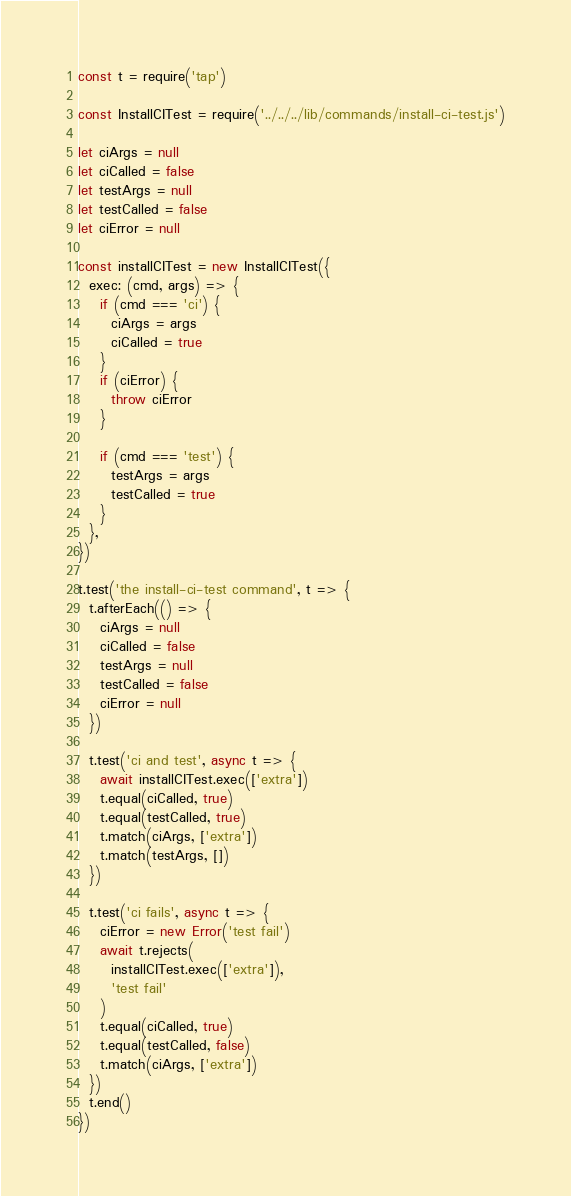<code> <loc_0><loc_0><loc_500><loc_500><_JavaScript_>const t = require('tap')

const InstallCITest = require('../../../lib/commands/install-ci-test.js')

let ciArgs = null
let ciCalled = false
let testArgs = null
let testCalled = false
let ciError = null

const installCITest = new InstallCITest({
  exec: (cmd, args) => {
    if (cmd === 'ci') {
      ciArgs = args
      ciCalled = true
    }
    if (ciError) {
      throw ciError
    }

    if (cmd === 'test') {
      testArgs = args
      testCalled = true
    }
  },
})

t.test('the install-ci-test command', t => {
  t.afterEach(() => {
    ciArgs = null
    ciCalled = false
    testArgs = null
    testCalled = false
    ciError = null
  })

  t.test('ci and test', async t => {
    await installCITest.exec(['extra'])
    t.equal(ciCalled, true)
    t.equal(testCalled, true)
    t.match(ciArgs, ['extra'])
    t.match(testArgs, [])
  })

  t.test('ci fails', async t => {
    ciError = new Error('test fail')
    await t.rejects(
      installCITest.exec(['extra']),
      'test fail'
    )
    t.equal(ciCalled, true)
    t.equal(testCalled, false)
    t.match(ciArgs, ['extra'])
  })
  t.end()
})
</code> 